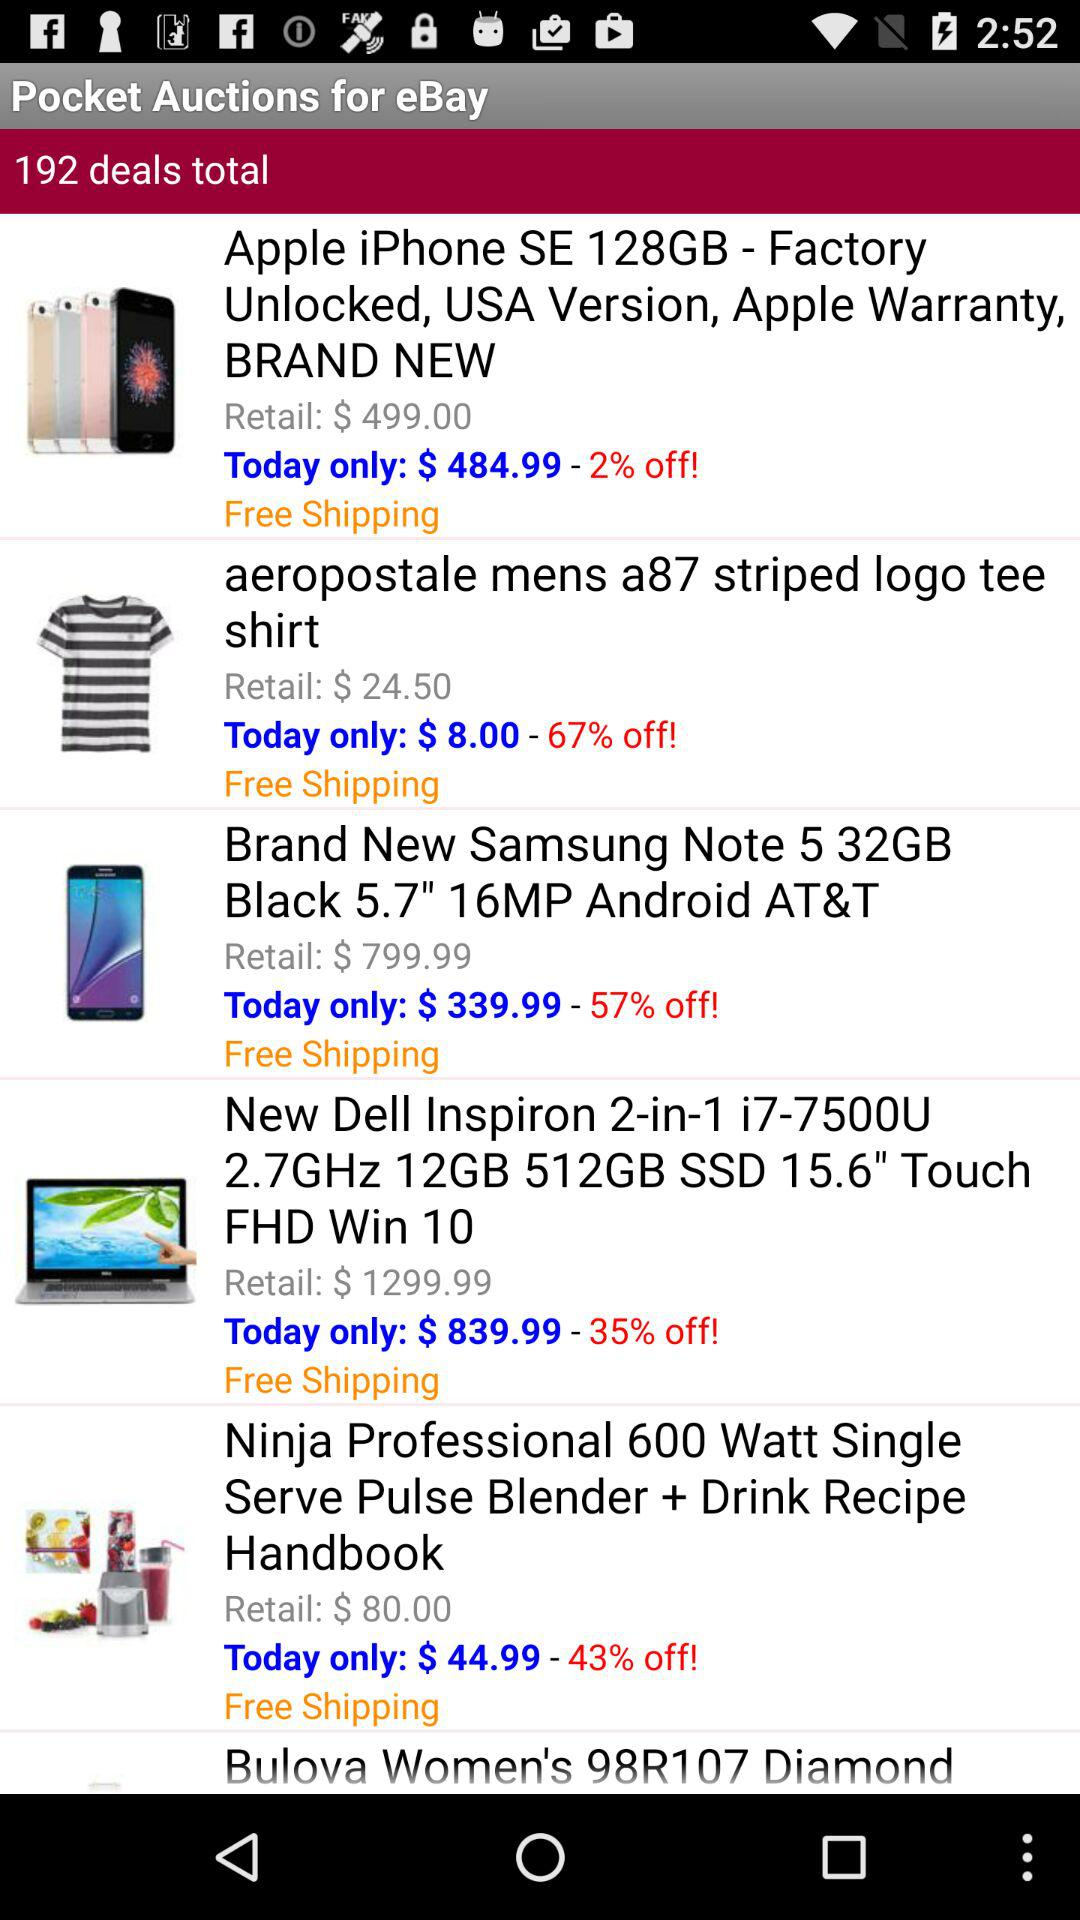What is the after-discount price of "Apple iPhone SE 128GB"? The after-discount price of "Apple iPhone SE 128GB" is $484.99. 